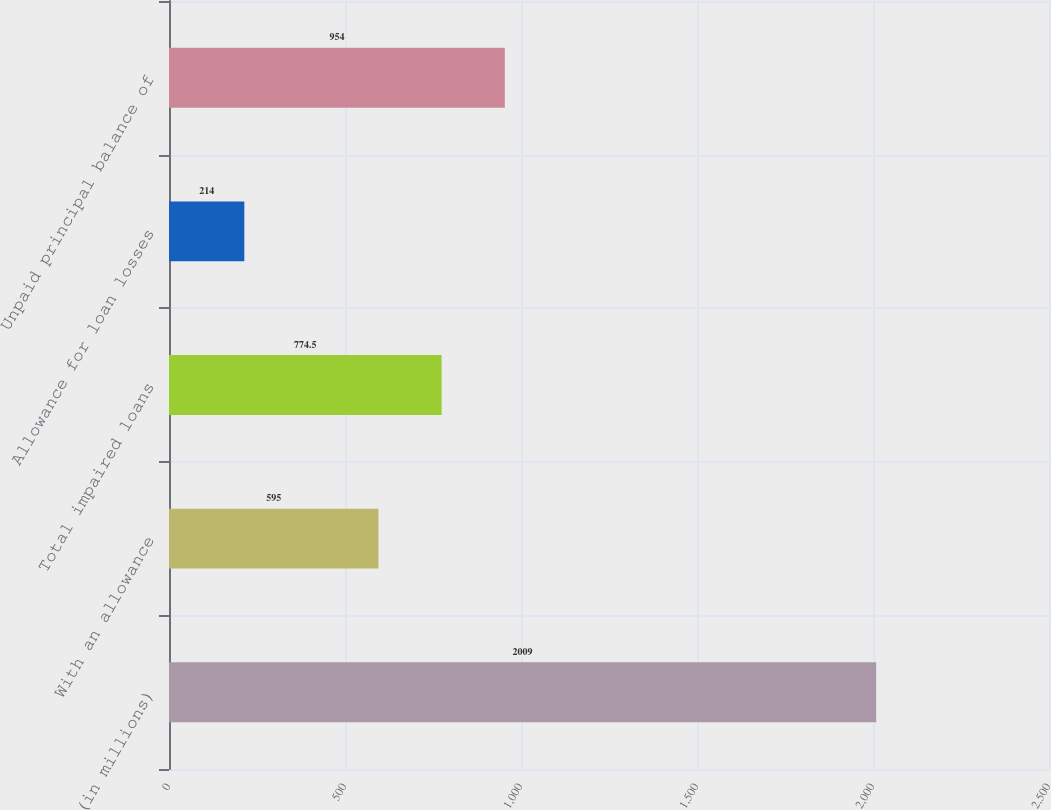<chart> <loc_0><loc_0><loc_500><loc_500><bar_chart><fcel>(in millions)<fcel>With an allowance<fcel>Total impaired loans<fcel>Allowance for loan losses<fcel>Unpaid principal balance of<nl><fcel>2009<fcel>595<fcel>774.5<fcel>214<fcel>954<nl></chart> 